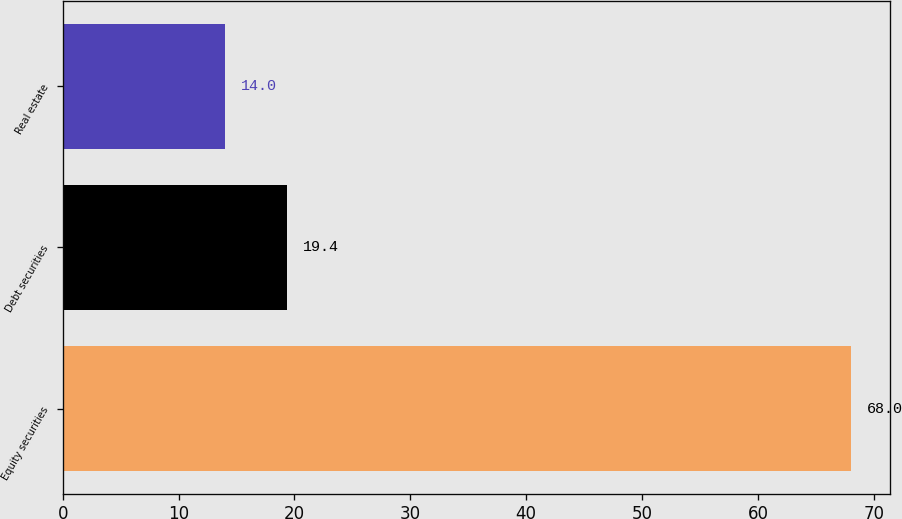Convert chart. <chart><loc_0><loc_0><loc_500><loc_500><bar_chart><fcel>Equity securities<fcel>Debt securities<fcel>Real estate<nl><fcel>68<fcel>19.4<fcel>14<nl></chart> 